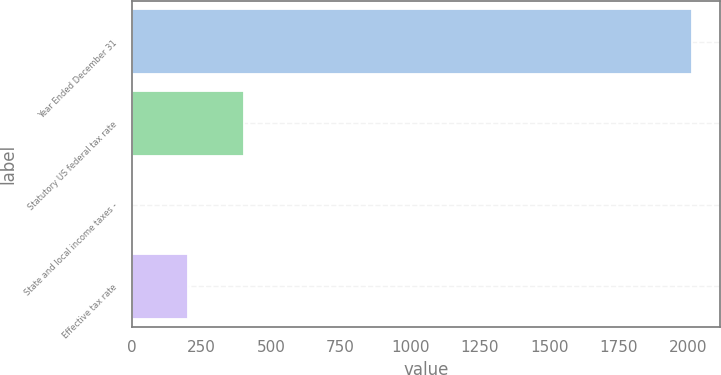Convert chart. <chart><loc_0><loc_0><loc_500><loc_500><bar_chart><fcel>Year Ended December 31<fcel>Statutory US federal tax rate<fcel>State and local income taxes -<fcel>Effective tax rate<nl><fcel>2014<fcel>403.6<fcel>1<fcel>202.3<nl></chart> 